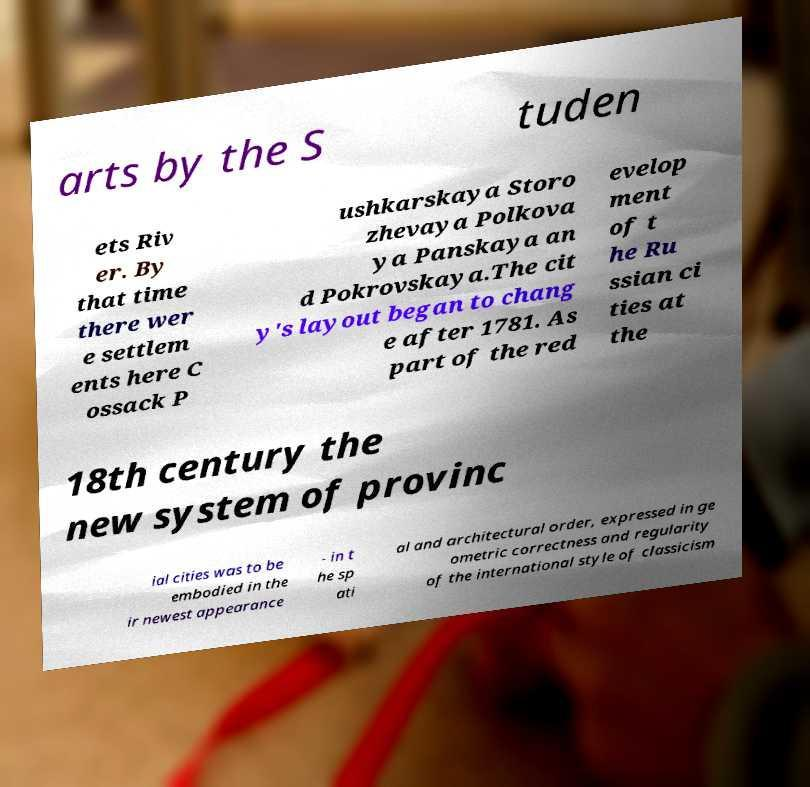Can you read and provide the text displayed in the image?This photo seems to have some interesting text. Can you extract and type it out for me? arts by the S tuden ets Riv er. By that time there wer e settlem ents here C ossack P ushkarskaya Storo zhevaya Polkova ya Panskaya an d Pokrovskaya.The cit y's layout began to chang e after 1781. As part of the red evelop ment of t he Ru ssian ci ties at the 18th century the new system of provinc ial cities was to be embodied in the ir newest appearance - in t he sp ati al and architectural order, expressed in ge ometric correctness and regularity of the international style of classicism 